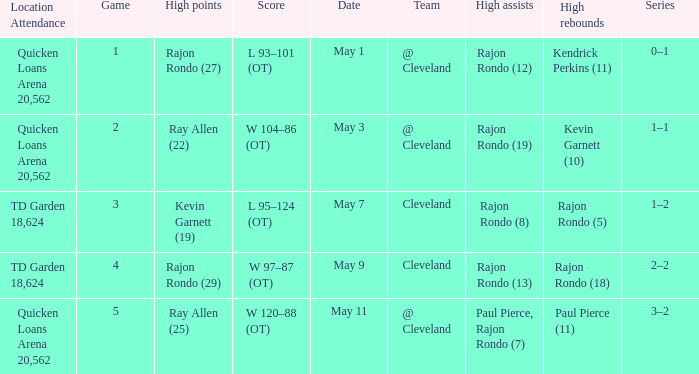Where does the team play May 3? @ Cleveland. 